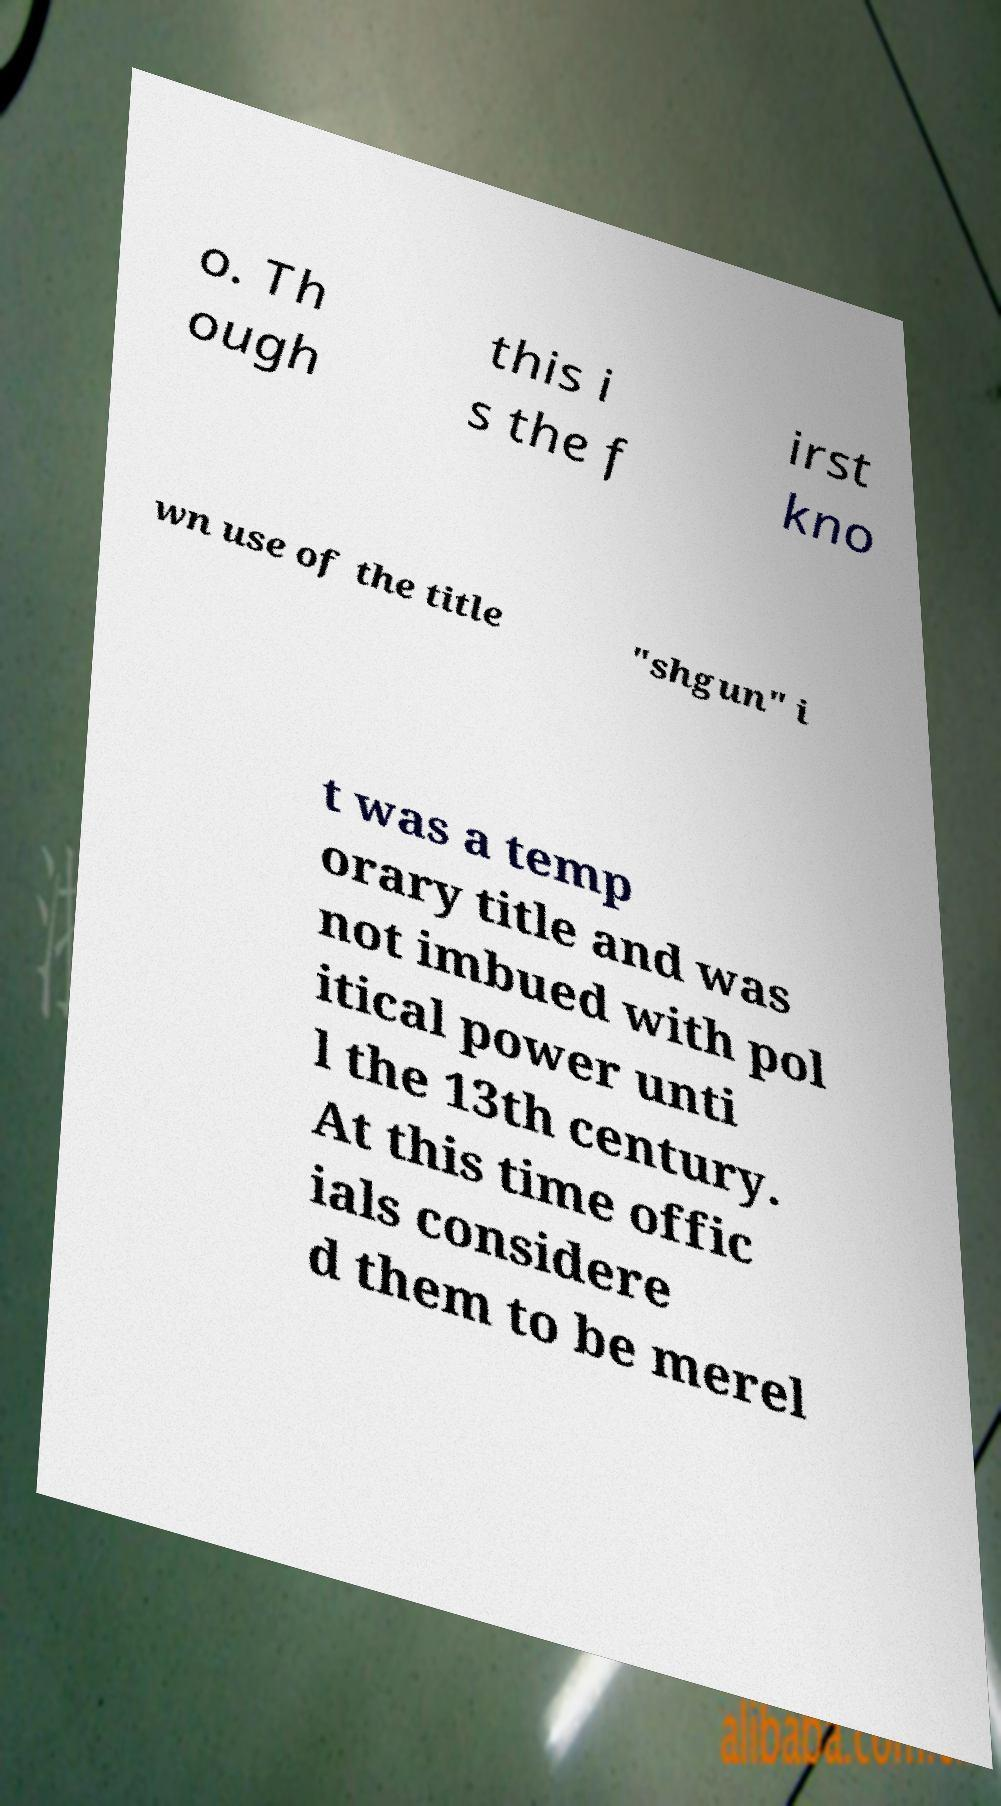Can you accurately transcribe the text from the provided image for me? o. Th ough this i s the f irst kno wn use of the title "shgun" i t was a temp orary title and was not imbued with pol itical power unti l the 13th century. At this time offic ials considere d them to be merel 